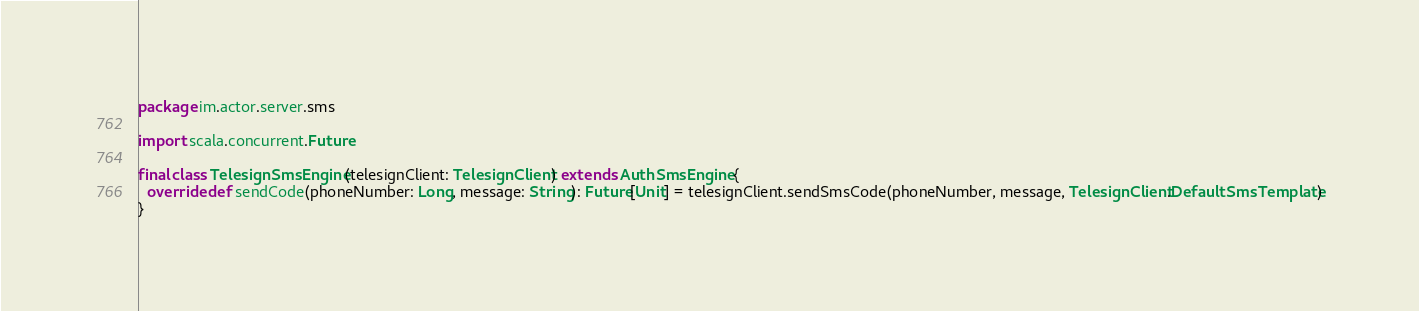Convert code to text. <code><loc_0><loc_0><loc_500><loc_500><_Scala_>package im.actor.server.sms

import scala.concurrent.Future

final class TelesignSmsEngine(telesignClient: TelesignClient) extends AuthSmsEngine {
  override def sendCode(phoneNumber: Long, message: String): Future[Unit] = telesignClient.sendSmsCode(phoneNumber, message, TelesignClient.DefaultSmsTemplate)
}
</code> 